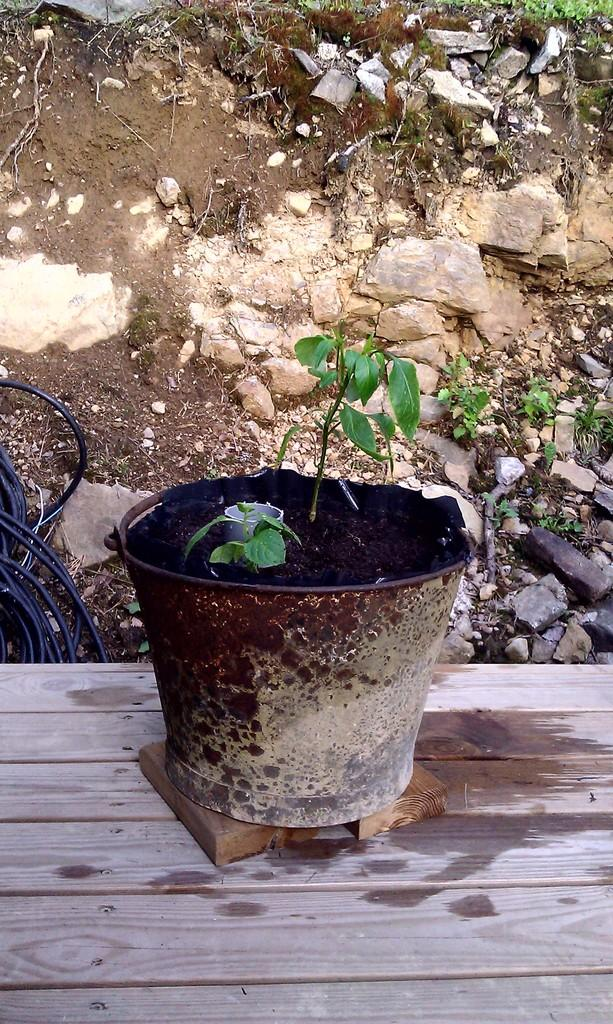What is located in the foreground of the image? There is a plant in the foreground of the image. What else can be seen in the image besides the plant? Wires, stones, grass, and a wooden object are visible in the image. Can you describe the wooden object at the bottom of the image? The wooden object at the bottom of the image is not specified in the facts, but it is present in the image. What type of natural environment is depicted in the image? The image features a plant, grass, and stones, suggesting a natural outdoor setting. What type of trail can be seen in the image? There is no trail visible in the image; it features a plant, wires, stones, grass, and a wooden object. How does the cough affect the wooden object in the image? There is no cough present in the image, and therefore no effect on the wooden object can be observed. 